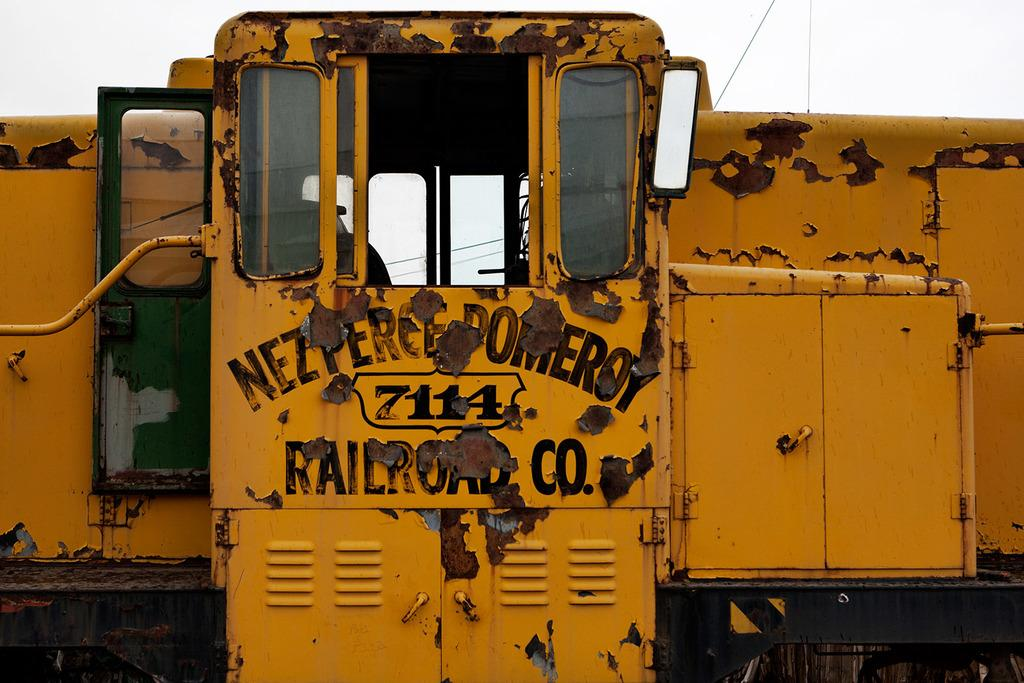What is the main subject of the image? There is a train in the image. What colors are used to depict the train? The train is yellow and black in color. What can be seen in the background of the image? The sky is visible in the background of the image. How many zebras are pulling the train in the image? There are no zebras present in the image, and therefore they cannot be pulling the train. 